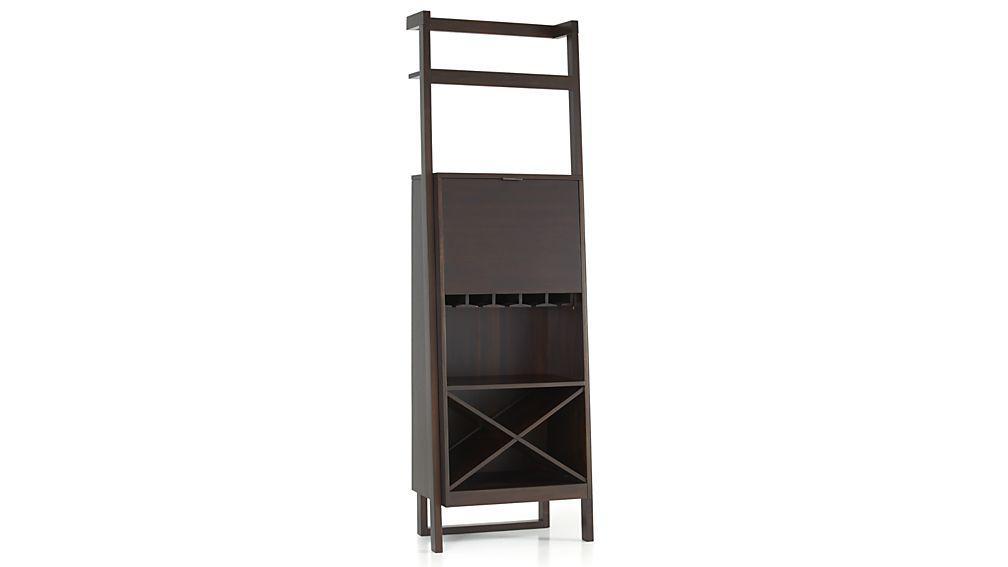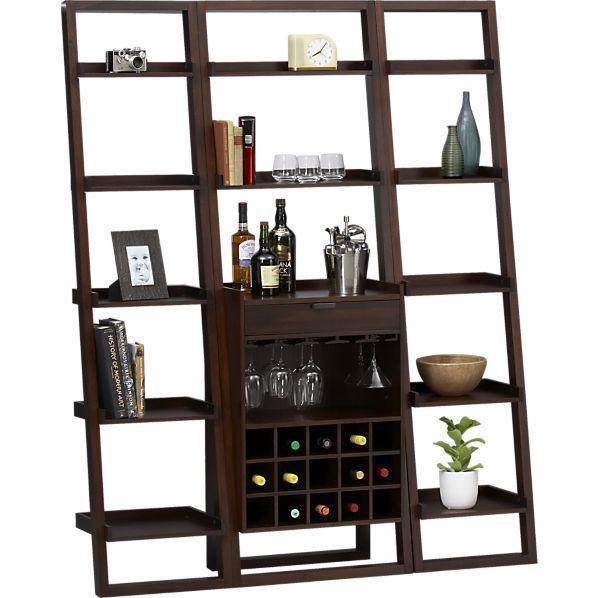The first image is the image on the left, the second image is the image on the right. Given the left and right images, does the statement "The shelf in the image on the left is white, while the shelf on the right is darker." hold true? Answer yes or no. No. The first image is the image on the left, the second image is the image on the right. Given the left and right images, does the statement "An image shows a dark storage unit with rows of shelves flanking an X-shaped compartment that holds wine bottles." hold true? Answer yes or no. No. 